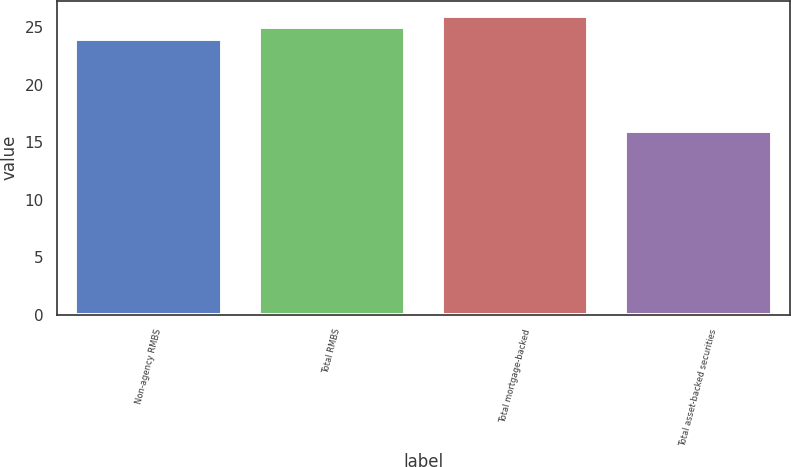<chart> <loc_0><loc_0><loc_500><loc_500><bar_chart><fcel>Non-agency RMBS<fcel>Total RMBS<fcel>Total mortgage-backed<fcel>Total asset-backed securities<nl><fcel>24<fcel>25<fcel>26<fcel>16<nl></chart> 